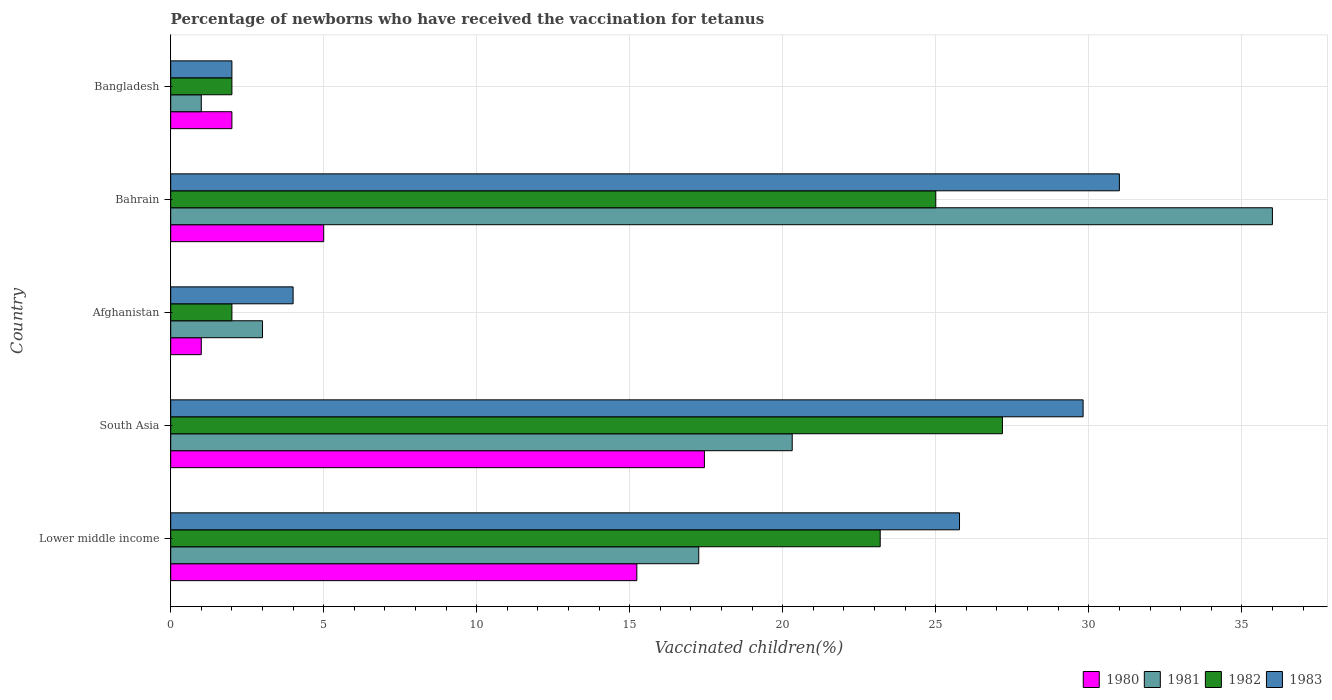How many different coloured bars are there?
Your answer should be very brief. 4. How many groups of bars are there?
Keep it short and to the point. 5. Are the number of bars per tick equal to the number of legend labels?
Provide a short and direct response. Yes. Are the number of bars on each tick of the Y-axis equal?
Your answer should be very brief. Yes. How many bars are there on the 5th tick from the top?
Provide a succinct answer. 4. How many bars are there on the 4th tick from the bottom?
Provide a succinct answer. 4. What is the label of the 5th group of bars from the top?
Offer a terse response. Lower middle income. In how many cases, is the number of bars for a given country not equal to the number of legend labels?
Ensure brevity in your answer.  0. What is the percentage of vaccinated children in 1980 in South Asia?
Provide a succinct answer. 17.44. In which country was the percentage of vaccinated children in 1981 maximum?
Your answer should be very brief. Bahrain. What is the total percentage of vaccinated children in 1981 in the graph?
Keep it short and to the point. 77.56. What is the difference between the percentage of vaccinated children in 1981 in Bangladesh and that in South Asia?
Make the answer very short. -19.31. What is the difference between the percentage of vaccinated children in 1982 in Bahrain and the percentage of vaccinated children in 1980 in Bangladesh?
Ensure brevity in your answer.  23. What is the average percentage of vaccinated children in 1981 per country?
Give a very brief answer. 15.51. What is the difference between the percentage of vaccinated children in 1982 and percentage of vaccinated children in 1981 in Lower middle income?
Make the answer very short. 5.93. In how many countries, is the percentage of vaccinated children in 1980 greater than 35 %?
Ensure brevity in your answer.  0. Is the percentage of vaccinated children in 1983 in Bahrain less than that in Lower middle income?
Offer a terse response. No. Is the difference between the percentage of vaccinated children in 1982 in Lower middle income and South Asia greater than the difference between the percentage of vaccinated children in 1981 in Lower middle income and South Asia?
Provide a succinct answer. No. What is the difference between the highest and the second highest percentage of vaccinated children in 1983?
Ensure brevity in your answer.  1.19. What is the difference between the highest and the lowest percentage of vaccinated children in 1982?
Your response must be concise. 25.18. In how many countries, is the percentage of vaccinated children in 1981 greater than the average percentage of vaccinated children in 1981 taken over all countries?
Offer a terse response. 3. What does the 1st bar from the top in Bangladesh represents?
Provide a short and direct response. 1983. What does the 2nd bar from the bottom in Lower middle income represents?
Provide a succinct answer. 1981. How many bars are there?
Make the answer very short. 20. How many legend labels are there?
Your response must be concise. 4. What is the title of the graph?
Make the answer very short. Percentage of newborns who have received the vaccination for tetanus. Does "2006" appear as one of the legend labels in the graph?
Your response must be concise. No. What is the label or title of the X-axis?
Offer a terse response. Vaccinated children(%). What is the Vaccinated children(%) of 1980 in Lower middle income?
Your answer should be very brief. 15.23. What is the Vaccinated children(%) of 1981 in Lower middle income?
Offer a very short reply. 17.25. What is the Vaccinated children(%) of 1982 in Lower middle income?
Your response must be concise. 23.18. What is the Vaccinated children(%) of 1983 in Lower middle income?
Offer a terse response. 25.78. What is the Vaccinated children(%) of 1980 in South Asia?
Your answer should be very brief. 17.44. What is the Vaccinated children(%) of 1981 in South Asia?
Ensure brevity in your answer.  20.31. What is the Vaccinated children(%) in 1982 in South Asia?
Your answer should be very brief. 27.18. What is the Vaccinated children(%) in 1983 in South Asia?
Your answer should be very brief. 29.81. What is the Vaccinated children(%) in 1981 in Afghanistan?
Ensure brevity in your answer.  3. What is the Vaccinated children(%) in 1982 in Afghanistan?
Provide a succinct answer. 2. What is the Vaccinated children(%) in 1981 in Bahrain?
Provide a succinct answer. 36. What is the Vaccinated children(%) of 1983 in Bahrain?
Make the answer very short. 31. What is the Vaccinated children(%) of 1980 in Bangladesh?
Your answer should be compact. 2. What is the Vaccinated children(%) in 1981 in Bangladesh?
Offer a terse response. 1. What is the Vaccinated children(%) of 1982 in Bangladesh?
Your response must be concise. 2. What is the Vaccinated children(%) in 1983 in Bangladesh?
Offer a terse response. 2. Across all countries, what is the maximum Vaccinated children(%) in 1980?
Provide a short and direct response. 17.44. Across all countries, what is the maximum Vaccinated children(%) of 1981?
Provide a succinct answer. 36. Across all countries, what is the maximum Vaccinated children(%) of 1982?
Provide a succinct answer. 27.18. Across all countries, what is the minimum Vaccinated children(%) of 1980?
Give a very brief answer. 1. Across all countries, what is the minimum Vaccinated children(%) in 1981?
Keep it short and to the point. 1. Across all countries, what is the minimum Vaccinated children(%) in 1982?
Your response must be concise. 2. Across all countries, what is the minimum Vaccinated children(%) of 1983?
Keep it short and to the point. 2. What is the total Vaccinated children(%) in 1980 in the graph?
Offer a terse response. 40.67. What is the total Vaccinated children(%) in 1981 in the graph?
Your answer should be very brief. 77.56. What is the total Vaccinated children(%) in 1982 in the graph?
Keep it short and to the point. 79.36. What is the total Vaccinated children(%) of 1983 in the graph?
Offer a terse response. 92.59. What is the difference between the Vaccinated children(%) of 1980 in Lower middle income and that in South Asia?
Provide a succinct answer. -2.21. What is the difference between the Vaccinated children(%) in 1981 in Lower middle income and that in South Asia?
Provide a short and direct response. -3.05. What is the difference between the Vaccinated children(%) of 1982 in Lower middle income and that in South Asia?
Give a very brief answer. -3.99. What is the difference between the Vaccinated children(%) in 1983 in Lower middle income and that in South Asia?
Your answer should be compact. -4.04. What is the difference between the Vaccinated children(%) of 1980 in Lower middle income and that in Afghanistan?
Keep it short and to the point. 14.23. What is the difference between the Vaccinated children(%) of 1981 in Lower middle income and that in Afghanistan?
Give a very brief answer. 14.25. What is the difference between the Vaccinated children(%) of 1982 in Lower middle income and that in Afghanistan?
Make the answer very short. 21.18. What is the difference between the Vaccinated children(%) of 1983 in Lower middle income and that in Afghanistan?
Offer a very short reply. 21.78. What is the difference between the Vaccinated children(%) of 1980 in Lower middle income and that in Bahrain?
Provide a succinct answer. 10.23. What is the difference between the Vaccinated children(%) of 1981 in Lower middle income and that in Bahrain?
Provide a succinct answer. -18.75. What is the difference between the Vaccinated children(%) of 1982 in Lower middle income and that in Bahrain?
Your answer should be compact. -1.82. What is the difference between the Vaccinated children(%) in 1983 in Lower middle income and that in Bahrain?
Provide a short and direct response. -5.22. What is the difference between the Vaccinated children(%) of 1980 in Lower middle income and that in Bangladesh?
Ensure brevity in your answer.  13.23. What is the difference between the Vaccinated children(%) of 1981 in Lower middle income and that in Bangladesh?
Ensure brevity in your answer.  16.25. What is the difference between the Vaccinated children(%) in 1982 in Lower middle income and that in Bangladesh?
Your answer should be compact. 21.18. What is the difference between the Vaccinated children(%) of 1983 in Lower middle income and that in Bangladesh?
Make the answer very short. 23.78. What is the difference between the Vaccinated children(%) of 1980 in South Asia and that in Afghanistan?
Offer a very short reply. 16.44. What is the difference between the Vaccinated children(%) of 1981 in South Asia and that in Afghanistan?
Provide a short and direct response. 17.31. What is the difference between the Vaccinated children(%) of 1982 in South Asia and that in Afghanistan?
Ensure brevity in your answer.  25.18. What is the difference between the Vaccinated children(%) in 1983 in South Asia and that in Afghanistan?
Provide a succinct answer. 25.81. What is the difference between the Vaccinated children(%) of 1980 in South Asia and that in Bahrain?
Provide a short and direct response. 12.44. What is the difference between the Vaccinated children(%) of 1981 in South Asia and that in Bahrain?
Your answer should be compact. -15.69. What is the difference between the Vaccinated children(%) of 1982 in South Asia and that in Bahrain?
Offer a terse response. 2.18. What is the difference between the Vaccinated children(%) of 1983 in South Asia and that in Bahrain?
Provide a short and direct response. -1.19. What is the difference between the Vaccinated children(%) in 1980 in South Asia and that in Bangladesh?
Your answer should be very brief. 15.44. What is the difference between the Vaccinated children(%) of 1981 in South Asia and that in Bangladesh?
Your answer should be compact. 19.31. What is the difference between the Vaccinated children(%) in 1982 in South Asia and that in Bangladesh?
Offer a terse response. 25.18. What is the difference between the Vaccinated children(%) in 1983 in South Asia and that in Bangladesh?
Provide a short and direct response. 27.81. What is the difference between the Vaccinated children(%) in 1981 in Afghanistan and that in Bahrain?
Make the answer very short. -33. What is the difference between the Vaccinated children(%) in 1983 in Afghanistan and that in Bahrain?
Give a very brief answer. -27. What is the difference between the Vaccinated children(%) in 1980 in Afghanistan and that in Bangladesh?
Offer a terse response. -1. What is the difference between the Vaccinated children(%) in 1981 in Afghanistan and that in Bangladesh?
Make the answer very short. 2. What is the difference between the Vaccinated children(%) in 1982 in Afghanistan and that in Bangladesh?
Your answer should be very brief. 0. What is the difference between the Vaccinated children(%) in 1981 in Bahrain and that in Bangladesh?
Give a very brief answer. 35. What is the difference between the Vaccinated children(%) of 1982 in Bahrain and that in Bangladesh?
Give a very brief answer. 23. What is the difference between the Vaccinated children(%) in 1983 in Bahrain and that in Bangladesh?
Your answer should be compact. 29. What is the difference between the Vaccinated children(%) in 1980 in Lower middle income and the Vaccinated children(%) in 1981 in South Asia?
Your response must be concise. -5.08. What is the difference between the Vaccinated children(%) in 1980 in Lower middle income and the Vaccinated children(%) in 1982 in South Asia?
Provide a short and direct response. -11.95. What is the difference between the Vaccinated children(%) in 1980 in Lower middle income and the Vaccinated children(%) in 1983 in South Asia?
Give a very brief answer. -14.58. What is the difference between the Vaccinated children(%) of 1981 in Lower middle income and the Vaccinated children(%) of 1982 in South Asia?
Offer a very short reply. -9.92. What is the difference between the Vaccinated children(%) in 1981 in Lower middle income and the Vaccinated children(%) in 1983 in South Asia?
Keep it short and to the point. -12.56. What is the difference between the Vaccinated children(%) in 1982 in Lower middle income and the Vaccinated children(%) in 1983 in South Asia?
Give a very brief answer. -6.63. What is the difference between the Vaccinated children(%) in 1980 in Lower middle income and the Vaccinated children(%) in 1981 in Afghanistan?
Provide a short and direct response. 12.23. What is the difference between the Vaccinated children(%) of 1980 in Lower middle income and the Vaccinated children(%) of 1982 in Afghanistan?
Your answer should be compact. 13.23. What is the difference between the Vaccinated children(%) of 1980 in Lower middle income and the Vaccinated children(%) of 1983 in Afghanistan?
Give a very brief answer. 11.23. What is the difference between the Vaccinated children(%) of 1981 in Lower middle income and the Vaccinated children(%) of 1982 in Afghanistan?
Offer a very short reply. 15.25. What is the difference between the Vaccinated children(%) of 1981 in Lower middle income and the Vaccinated children(%) of 1983 in Afghanistan?
Provide a short and direct response. 13.25. What is the difference between the Vaccinated children(%) of 1982 in Lower middle income and the Vaccinated children(%) of 1983 in Afghanistan?
Your answer should be very brief. 19.18. What is the difference between the Vaccinated children(%) of 1980 in Lower middle income and the Vaccinated children(%) of 1981 in Bahrain?
Offer a terse response. -20.77. What is the difference between the Vaccinated children(%) in 1980 in Lower middle income and the Vaccinated children(%) in 1982 in Bahrain?
Make the answer very short. -9.77. What is the difference between the Vaccinated children(%) of 1980 in Lower middle income and the Vaccinated children(%) of 1983 in Bahrain?
Ensure brevity in your answer.  -15.77. What is the difference between the Vaccinated children(%) of 1981 in Lower middle income and the Vaccinated children(%) of 1982 in Bahrain?
Your response must be concise. -7.75. What is the difference between the Vaccinated children(%) of 1981 in Lower middle income and the Vaccinated children(%) of 1983 in Bahrain?
Ensure brevity in your answer.  -13.75. What is the difference between the Vaccinated children(%) of 1982 in Lower middle income and the Vaccinated children(%) of 1983 in Bahrain?
Offer a very short reply. -7.82. What is the difference between the Vaccinated children(%) in 1980 in Lower middle income and the Vaccinated children(%) in 1981 in Bangladesh?
Your answer should be compact. 14.23. What is the difference between the Vaccinated children(%) of 1980 in Lower middle income and the Vaccinated children(%) of 1982 in Bangladesh?
Your answer should be very brief. 13.23. What is the difference between the Vaccinated children(%) of 1980 in Lower middle income and the Vaccinated children(%) of 1983 in Bangladesh?
Your answer should be very brief. 13.23. What is the difference between the Vaccinated children(%) of 1981 in Lower middle income and the Vaccinated children(%) of 1982 in Bangladesh?
Provide a succinct answer. 15.25. What is the difference between the Vaccinated children(%) of 1981 in Lower middle income and the Vaccinated children(%) of 1983 in Bangladesh?
Your response must be concise. 15.25. What is the difference between the Vaccinated children(%) in 1982 in Lower middle income and the Vaccinated children(%) in 1983 in Bangladesh?
Make the answer very short. 21.18. What is the difference between the Vaccinated children(%) in 1980 in South Asia and the Vaccinated children(%) in 1981 in Afghanistan?
Provide a succinct answer. 14.44. What is the difference between the Vaccinated children(%) in 1980 in South Asia and the Vaccinated children(%) in 1982 in Afghanistan?
Give a very brief answer. 15.44. What is the difference between the Vaccinated children(%) of 1980 in South Asia and the Vaccinated children(%) of 1983 in Afghanistan?
Your answer should be very brief. 13.44. What is the difference between the Vaccinated children(%) in 1981 in South Asia and the Vaccinated children(%) in 1982 in Afghanistan?
Make the answer very short. 18.31. What is the difference between the Vaccinated children(%) of 1981 in South Asia and the Vaccinated children(%) of 1983 in Afghanistan?
Provide a succinct answer. 16.31. What is the difference between the Vaccinated children(%) of 1982 in South Asia and the Vaccinated children(%) of 1983 in Afghanistan?
Give a very brief answer. 23.18. What is the difference between the Vaccinated children(%) of 1980 in South Asia and the Vaccinated children(%) of 1981 in Bahrain?
Give a very brief answer. -18.56. What is the difference between the Vaccinated children(%) in 1980 in South Asia and the Vaccinated children(%) in 1982 in Bahrain?
Make the answer very short. -7.56. What is the difference between the Vaccinated children(%) in 1980 in South Asia and the Vaccinated children(%) in 1983 in Bahrain?
Your response must be concise. -13.56. What is the difference between the Vaccinated children(%) of 1981 in South Asia and the Vaccinated children(%) of 1982 in Bahrain?
Keep it short and to the point. -4.69. What is the difference between the Vaccinated children(%) in 1981 in South Asia and the Vaccinated children(%) in 1983 in Bahrain?
Give a very brief answer. -10.69. What is the difference between the Vaccinated children(%) in 1982 in South Asia and the Vaccinated children(%) in 1983 in Bahrain?
Offer a terse response. -3.82. What is the difference between the Vaccinated children(%) in 1980 in South Asia and the Vaccinated children(%) in 1981 in Bangladesh?
Provide a succinct answer. 16.44. What is the difference between the Vaccinated children(%) of 1980 in South Asia and the Vaccinated children(%) of 1982 in Bangladesh?
Provide a succinct answer. 15.44. What is the difference between the Vaccinated children(%) of 1980 in South Asia and the Vaccinated children(%) of 1983 in Bangladesh?
Offer a very short reply. 15.44. What is the difference between the Vaccinated children(%) of 1981 in South Asia and the Vaccinated children(%) of 1982 in Bangladesh?
Ensure brevity in your answer.  18.31. What is the difference between the Vaccinated children(%) in 1981 in South Asia and the Vaccinated children(%) in 1983 in Bangladesh?
Give a very brief answer. 18.31. What is the difference between the Vaccinated children(%) of 1982 in South Asia and the Vaccinated children(%) of 1983 in Bangladesh?
Give a very brief answer. 25.18. What is the difference between the Vaccinated children(%) of 1980 in Afghanistan and the Vaccinated children(%) of 1981 in Bahrain?
Provide a succinct answer. -35. What is the difference between the Vaccinated children(%) of 1980 in Afghanistan and the Vaccinated children(%) of 1982 in Bahrain?
Your answer should be compact. -24. What is the difference between the Vaccinated children(%) of 1981 in Afghanistan and the Vaccinated children(%) of 1982 in Bahrain?
Keep it short and to the point. -22. What is the difference between the Vaccinated children(%) in 1981 in Afghanistan and the Vaccinated children(%) in 1983 in Bahrain?
Make the answer very short. -28. What is the difference between the Vaccinated children(%) in 1982 in Afghanistan and the Vaccinated children(%) in 1983 in Bahrain?
Ensure brevity in your answer.  -29. What is the difference between the Vaccinated children(%) in 1980 in Afghanistan and the Vaccinated children(%) in 1981 in Bangladesh?
Give a very brief answer. 0. What is the difference between the Vaccinated children(%) in 1981 in Afghanistan and the Vaccinated children(%) in 1983 in Bangladesh?
Provide a succinct answer. 1. What is the difference between the Vaccinated children(%) in 1980 in Bahrain and the Vaccinated children(%) in 1981 in Bangladesh?
Your response must be concise. 4. What is the difference between the Vaccinated children(%) in 1980 in Bahrain and the Vaccinated children(%) in 1983 in Bangladesh?
Give a very brief answer. 3. What is the average Vaccinated children(%) in 1980 per country?
Your answer should be very brief. 8.13. What is the average Vaccinated children(%) in 1981 per country?
Your answer should be compact. 15.51. What is the average Vaccinated children(%) in 1982 per country?
Offer a very short reply. 15.87. What is the average Vaccinated children(%) of 1983 per country?
Your answer should be very brief. 18.52. What is the difference between the Vaccinated children(%) in 1980 and Vaccinated children(%) in 1981 in Lower middle income?
Ensure brevity in your answer.  -2.02. What is the difference between the Vaccinated children(%) of 1980 and Vaccinated children(%) of 1982 in Lower middle income?
Your answer should be compact. -7.95. What is the difference between the Vaccinated children(%) in 1980 and Vaccinated children(%) in 1983 in Lower middle income?
Offer a terse response. -10.54. What is the difference between the Vaccinated children(%) in 1981 and Vaccinated children(%) in 1982 in Lower middle income?
Your answer should be compact. -5.93. What is the difference between the Vaccinated children(%) of 1981 and Vaccinated children(%) of 1983 in Lower middle income?
Provide a short and direct response. -8.52. What is the difference between the Vaccinated children(%) in 1982 and Vaccinated children(%) in 1983 in Lower middle income?
Provide a short and direct response. -2.59. What is the difference between the Vaccinated children(%) of 1980 and Vaccinated children(%) of 1981 in South Asia?
Give a very brief answer. -2.87. What is the difference between the Vaccinated children(%) of 1980 and Vaccinated children(%) of 1982 in South Asia?
Keep it short and to the point. -9.74. What is the difference between the Vaccinated children(%) of 1980 and Vaccinated children(%) of 1983 in South Asia?
Your response must be concise. -12.37. What is the difference between the Vaccinated children(%) of 1981 and Vaccinated children(%) of 1982 in South Asia?
Your answer should be very brief. -6.87. What is the difference between the Vaccinated children(%) in 1981 and Vaccinated children(%) in 1983 in South Asia?
Your answer should be very brief. -9.51. What is the difference between the Vaccinated children(%) of 1982 and Vaccinated children(%) of 1983 in South Asia?
Give a very brief answer. -2.64. What is the difference between the Vaccinated children(%) in 1980 and Vaccinated children(%) in 1983 in Afghanistan?
Your answer should be very brief. -3. What is the difference between the Vaccinated children(%) of 1981 and Vaccinated children(%) of 1983 in Afghanistan?
Ensure brevity in your answer.  -1. What is the difference between the Vaccinated children(%) in 1980 and Vaccinated children(%) in 1981 in Bahrain?
Make the answer very short. -31. What is the difference between the Vaccinated children(%) of 1980 and Vaccinated children(%) of 1982 in Bahrain?
Provide a short and direct response. -20. What is the difference between the Vaccinated children(%) of 1980 and Vaccinated children(%) of 1983 in Bahrain?
Provide a short and direct response. -26. What is the difference between the Vaccinated children(%) in 1981 and Vaccinated children(%) in 1982 in Bahrain?
Provide a succinct answer. 11. What is the difference between the Vaccinated children(%) of 1981 and Vaccinated children(%) of 1983 in Bahrain?
Offer a very short reply. 5. What is the difference between the Vaccinated children(%) of 1980 and Vaccinated children(%) of 1981 in Bangladesh?
Provide a short and direct response. 1. What is the difference between the Vaccinated children(%) in 1980 and Vaccinated children(%) in 1983 in Bangladesh?
Make the answer very short. 0. What is the difference between the Vaccinated children(%) in 1982 and Vaccinated children(%) in 1983 in Bangladesh?
Provide a short and direct response. 0. What is the ratio of the Vaccinated children(%) of 1980 in Lower middle income to that in South Asia?
Give a very brief answer. 0.87. What is the ratio of the Vaccinated children(%) of 1981 in Lower middle income to that in South Asia?
Give a very brief answer. 0.85. What is the ratio of the Vaccinated children(%) of 1982 in Lower middle income to that in South Asia?
Ensure brevity in your answer.  0.85. What is the ratio of the Vaccinated children(%) in 1983 in Lower middle income to that in South Asia?
Offer a terse response. 0.86. What is the ratio of the Vaccinated children(%) of 1980 in Lower middle income to that in Afghanistan?
Keep it short and to the point. 15.23. What is the ratio of the Vaccinated children(%) in 1981 in Lower middle income to that in Afghanistan?
Ensure brevity in your answer.  5.75. What is the ratio of the Vaccinated children(%) in 1982 in Lower middle income to that in Afghanistan?
Offer a very short reply. 11.59. What is the ratio of the Vaccinated children(%) in 1983 in Lower middle income to that in Afghanistan?
Provide a succinct answer. 6.44. What is the ratio of the Vaccinated children(%) of 1980 in Lower middle income to that in Bahrain?
Your answer should be very brief. 3.05. What is the ratio of the Vaccinated children(%) in 1981 in Lower middle income to that in Bahrain?
Keep it short and to the point. 0.48. What is the ratio of the Vaccinated children(%) of 1982 in Lower middle income to that in Bahrain?
Give a very brief answer. 0.93. What is the ratio of the Vaccinated children(%) in 1983 in Lower middle income to that in Bahrain?
Provide a short and direct response. 0.83. What is the ratio of the Vaccinated children(%) of 1980 in Lower middle income to that in Bangladesh?
Your response must be concise. 7.62. What is the ratio of the Vaccinated children(%) in 1981 in Lower middle income to that in Bangladesh?
Provide a short and direct response. 17.25. What is the ratio of the Vaccinated children(%) in 1982 in Lower middle income to that in Bangladesh?
Offer a very short reply. 11.59. What is the ratio of the Vaccinated children(%) in 1983 in Lower middle income to that in Bangladesh?
Provide a short and direct response. 12.89. What is the ratio of the Vaccinated children(%) in 1980 in South Asia to that in Afghanistan?
Your answer should be compact. 17.44. What is the ratio of the Vaccinated children(%) of 1981 in South Asia to that in Afghanistan?
Ensure brevity in your answer.  6.77. What is the ratio of the Vaccinated children(%) in 1982 in South Asia to that in Afghanistan?
Provide a short and direct response. 13.59. What is the ratio of the Vaccinated children(%) of 1983 in South Asia to that in Afghanistan?
Your answer should be compact. 7.45. What is the ratio of the Vaccinated children(%) in 1980 in South Asia to that in Bahrain?
Ensure brevity in your answer.  3.49. What is the ratio of the Vaccinated children(%) in 1981 in South Asia to that in Bahrain?
Make the answer very short. 0.56. What is the ratio of the Vaccinated children(%) of 1982 in South Asia to that in Bahrain?
Give a very brief answer. 1.09. What is the ratio of the Vaccinated children(%) of 1983 in South Asia to that in Bahrain?
Your answer should be very brief. 0.96. What is the ratio of the Vaccinated children(%) of 1980 in South Asia to that in Bangladesh?
Make the answer very short. 8.72. What is the ratio of the Vaccinated children(%) in 1981 in South Asia to that in Bangladesh?
Your answer should be very brief. 20.31. What is the ratio of the Vaccinated children(%) in 1982 in South Asia to that in Bangladesh?
Make the answer very short. 13.59. What is the ratio of the Vaccinated children(%) of 1983 in South Asia to that in Bangladesh?
Offer a terse response. 14.91. What is the ratio of the Vaccinated children(%) in 1980 in Afghanistan to that in Bahrain?
Ensure brevity in your answer.  0.2. What is the ratio of the Vaccinated children(%) in 1981 in Afghanistan to that in Bahrain?
Offer a very short reply. 0.08. What is the ratio of the Vaccinated children(%) in 1983 in Afghanistan to that in Bahrain?
Ensure brevity in your answer.  0.13. What is the ratio of the Vaccinated children(%) in 1982 in Afghanistan to that in Bangladesh?
Provide a succinct answer. 1. What is the ratio of the Vaccinated children(%) in 1983 in Afghanistan to that in Bangladesh?
Your response must be concise. 2. What is the ratio of the Vaccinated children(%) in 1981 in Bahrain to that in Bangladesh?
Provide a short and direct response. 36. What is the ratio of the Vaccinated children(%) in 1983 in Bahrain to that in Bangladesh?
Your answer should be very brief. 15.5. What is the difference between the highest and the second highest Vaccinated children(%) in 1980?
Ensure brevity in your answer.  2.21. What is the difference between the highest and the second highest Vaccinated children(%) of 1981?
Provide a short and direct response. 15.69. What is the difference between the highest and the second highest Vaccinated children(%) of 1982?
Make the answer very short. 2.18. What is the difference between the highest and the second highest Vaccinated children(%) in 1983?
Offer a terse response. 1.19. What is the difference between the highest and the lowest Vaccinated children(%) in 1980?
Make the answer very short. 16.44. What is the difference between the highest and the lowest Vaccinated children(%) of 1981?
Offer a terse response. 35. What is the difference between the highest and the lowest Vaccinated children(%) of 1982?
Offer a terse response. 25.18. 